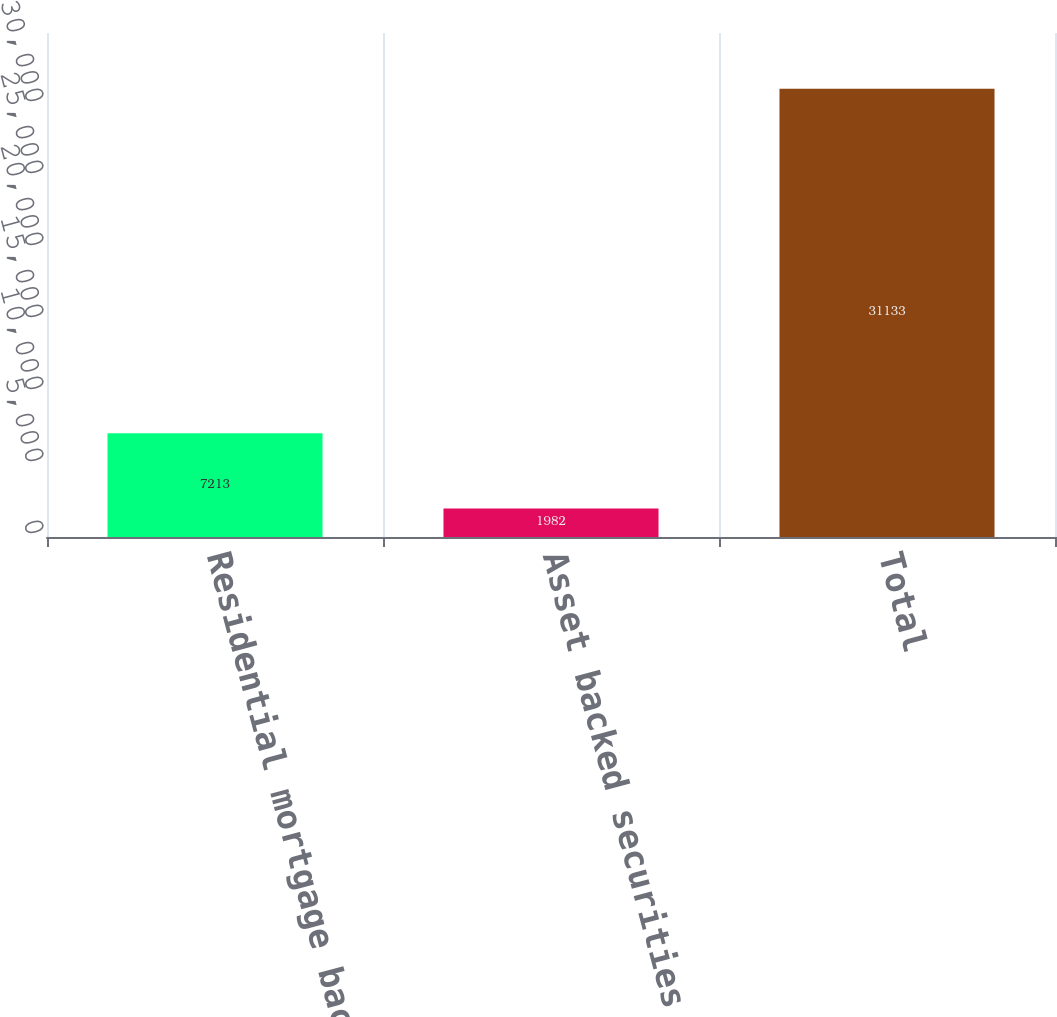Convert chart to OTSL. <chart><loc_0><loc_0><loc_500><loc_500><bar_chart><fcel>Residential mortgage backed<fcel>Asset backed securities<fcel>Total<nl><fcel>7213<fcel>1982<fcel>31133<nl></chart> 